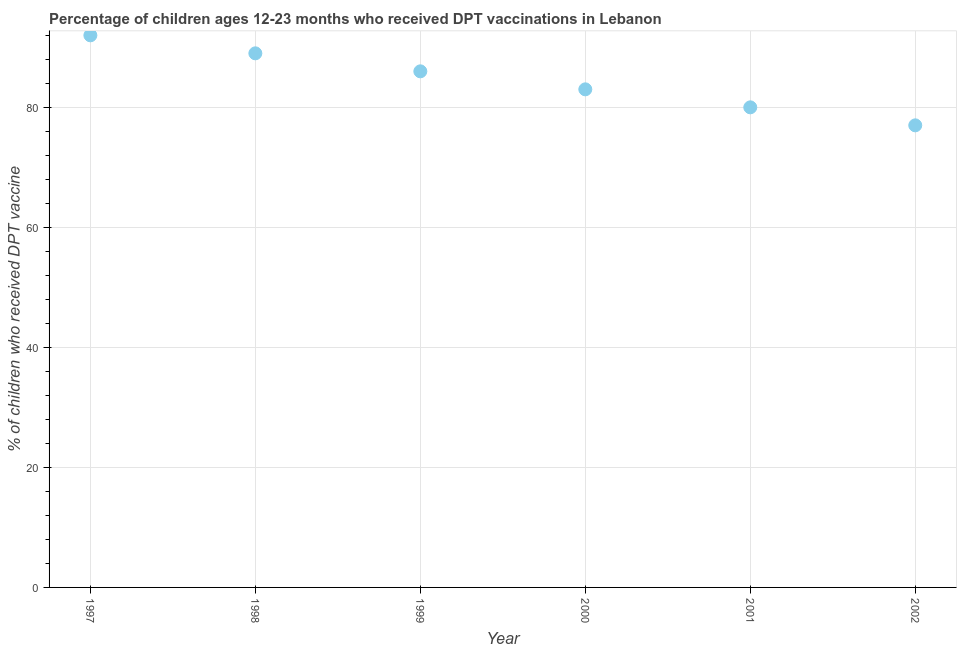What is the percentage of children who received dpt vaccine in 1998?
Your answer should be very brief. 89. Across all years, what is the maximum percentage of children who received dpt vaccine?
Give a very brief answer. 92. Across all years, what is the minimum percentage of children who received dpt vaccine?
Ensure brevity in your answer.  77. What is the sum of the percentage of children who received dpt vaccine?
Give a very brief answer. 507. What is the difference between the percentage of children who received dpt vaccine in 1998 and 1999?
Provide a short and direct response. 3. What is the average percentage of children who received dpt vaccine per year?
Provide a succinct answer. 84.5. What is the median percentage of children who received dpt vaccine?
Give a very brief answer. 84.5. Do a majority of the years between 1999 and 1997 (inclusive) have percentage of children who received dpt vaccine greater than 36 %?
Make the answer very short. No. What is the ratio of the percentage of children who received dpt vaccine in 2000 to that in 2002?
Ensure brevity in your answer.  1.08. Is the percentage of children who received dpt vaccine in 1997 less than that in 1998?
Your response must be concise. No. What is the difference between the highest and the second highest percentage of children who received dpt vaccine?
Provide a short and direct response. 3. Is the sum of the percentage of children who received dpt vaccine in 2000 and 2001 greater than the maximum percentage of children who received dpt vaccine across all years?
Your answer should be compact. Yes. What is the difference between the highest and the lowest percentage of children who received dpt vaccine?
Provide a succinct answer. 15. Does the percentage of children who received dpt vaccine monotonically increase over the years?
Offer a terse response. No. How many dotlines are there?
Your answer should be compact. 1. What is the difference between two consecutive major ticks on the Y-axis?
Make the answer very short. 20. What is the title of the graph?
Provide a succinct answer. Percentage of children ages 12-23 months who received DPT vaccinations in Lebanon. What is the label or title of the X-axis?
Provide a short and direct response. Year. What is the label or title of the Y-axis?
Offer a very short reply. % of children who received DPT vaccine. What is the % of children who received DPT vaccine in 1997?
Keep it short and to the point. 92. What is the % of children who received DPT vaccine in 1998?
Ensure brevity in your answer.  89. What is the % of children who received DPT vaccine in 1999?
Your answer should be compact. 86. What is the % of children who received DPT vaccine in 2000?
Provide a succinct answer. 83. What is the difference between the % of children who received DPT vaccine in 1997 and 1998?
Offer a terse response. 3. What is the difference between the % of children who received DPT vaccine in 1997 and 1999?
Provide a short and direct response. 6. What is the difference between the % of children who received DPT vaccine in 1997 and 2000?
Give a very brief answer. 9. What is the difference between the % of children who received DPT vaccine in 1997 and 2002?
Give a very brief answer. 15. What is the difference between the % of children who received DPT vaccine in 1998 and 1999?
Give a very brief answer. 3. What is the difference between the % of children who received DPT vaccine in 1998 and 2000?
Your response must be concise. 6. What is the difference between the % of children who received DPT vaccine in 1998 and 2001?
Offer a terse response. 9. What is the difference between the % of children who received DPT vaccine in 1998 and 2002?
Your answer should be very brief. 12. What is the difference between the % of children who received DPT vaccine in 1999 and 2000?
Provide a succinct answer. 3. What is the difference between the % of children who received DPT vaccine in 1999 and 2001?
Your response must be concise. 6. What is the difference between the % of children who received DPT vaccine in 2000 and 2002?
Your response must be concise. 6. What is the difference between the % of children who received DPT vaccine in 2001 and 2002?
Give a very brief answer. 3. What is the ratio of the % of children who received DPT vaccine in 1997 to that in 1998?
Offer a very short reply. 1.03. What is the ratio of the % of children who received DPT vaccine in 1997 to that in 1999?
Provide a succinct answer. 1.07. What is the ratio of the % of children who received DPT vaccine in 1997 to that in 2000?
Ensure brevity in your answer.  1.11. What is the ratio of the % of children who received DPT vaccine in 1997 to that in 2001?
Provide a short and direct response. 1.15. What is the ratio of the % of children who received DPT vaccine in 1997 to that in 2002?
Keep it short and to the point. 1.2. What is the ratio of the % of children who received DPT vaccine in 1998 to that in 1999?
Your answer should be compact. 1.03. What is the ratio of the % of children who received DPT vaccine in 1998 to that in 2000?
Provide a short and direct response. 1.07. What is the ratio of the % of children who received DPT vaccine in 1998 to that in 2001?
Provide a short and direct response. 1.11. What is the ratio of the % of children who received DPT vaccine in 1998 to that in 2002?
Your answer should be very brief. 1.16. What is the ratio of the % of children who received DPT vaccine in 1999 to that in 2000?
Provide a succinct answer. 1.04. What is the ratio of the % of children who received DPT vaccine in 1999 to that in 2001?
Offer a terse response. 1.07. What is the ratio of the % of children who received DPT vaccine in 1999 to that in 2002?
Give a very brief answer. 1.12. What is the ratio of the % of children who received DPT vaccine in 2000 to that in 2001?
Provide a succinct answer. 1.04. What is the ratio of the % of children who received DPT vaccine in 2000 to that in 2002?
Give a very brief answer. 1.08. What is the ratio of the % of children who received DPT vaccine in 2001 to that in 2002?
Give a very brief answer. 1.04. 